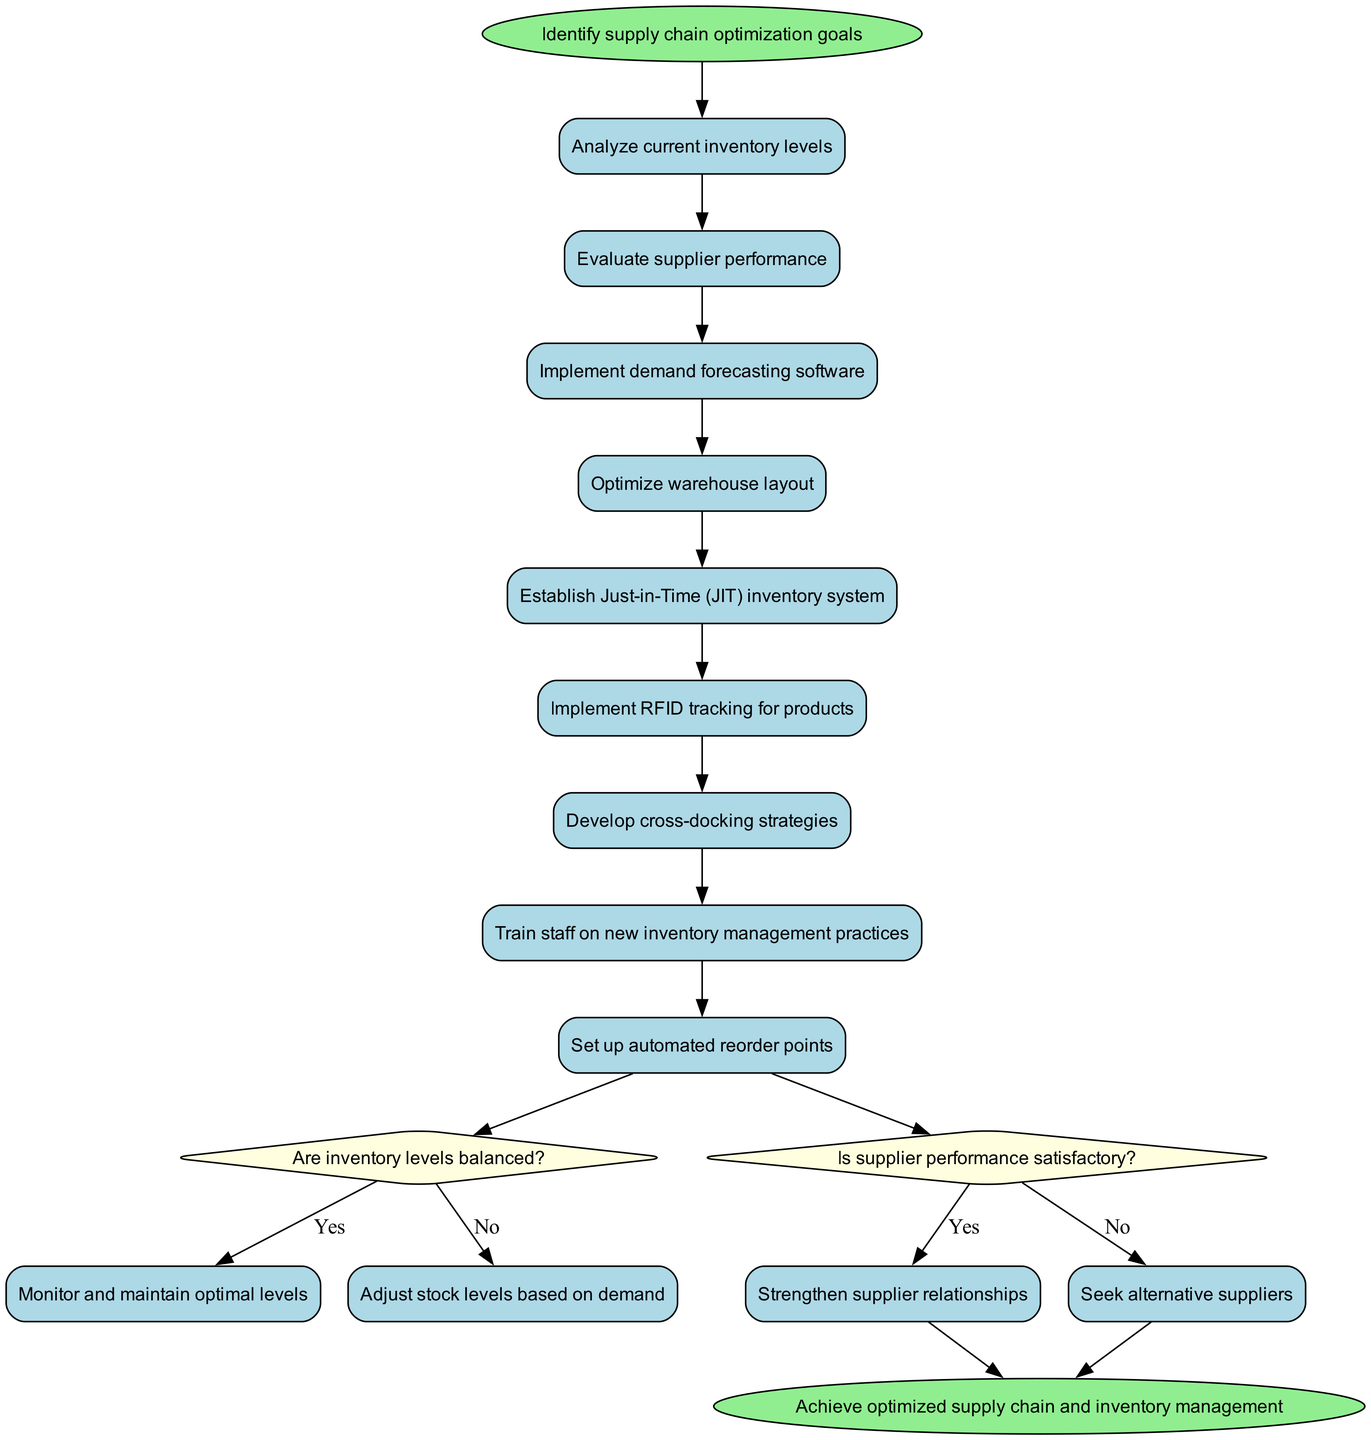What is the starting point of the diagram? The starting point is identified as "Identify supply chain optimization goals" which is marked as the first node in the diagram before any activities begin.
Answer: Identify supply chain optimization goals How many activities are there in total? By counting all the activities listed in the diagram, there are a total of 9 activities, as detailed in the activities section of the data.
Answer: 9 What decision follows the last activity in the diagram? The last activity is "Set up automated reorder points," which leads to the first decision question: "Are inventory levels balanced?"
Answer: Are inventory levels balanced? What are the two outcomes from the first decision? The decision "Are inventory levels balanced?" leads to two outcomes: "Monitor and maintain optimal levels" for a yes answer and "Adjust stock levels based on demand" for a no answer.
Answer: Monitor and maintain optimal levels, Adjust stock levels based on demand If the answer to the second decision is yes, what is the next action? The second decision is "Is supplier performance satisfactory?" If the answer is yes, the next action is to "Strengthen supplier relationships" as denoted in the diagram's flow.
Answer: Strengthen supplier relationships What happens if the answer to the second decision is no? If the answer to "Is supplier performance satisfactory?" is no, the flow directs to "Seek alternative suppliers," which indicates the next action to take based on that decision.
Answer: Seek alternative suppliers What is the final node in the activity diagram? The final node, indicating the end of the process flow, is labeled as "Achieve optimized supply chain and inventory management" which signifies the outcome after going through the activities and decisions.
Answer: Achieve optimized supply chain and inventory management Describe the link between the last 'yes' decision and the end node. The last 'yes' decision from the second question leads directly to the end node, meaning that if both decisions yield positive outcomes, the process concludes successfully with optimized management.
Answer: Direct link to end node 